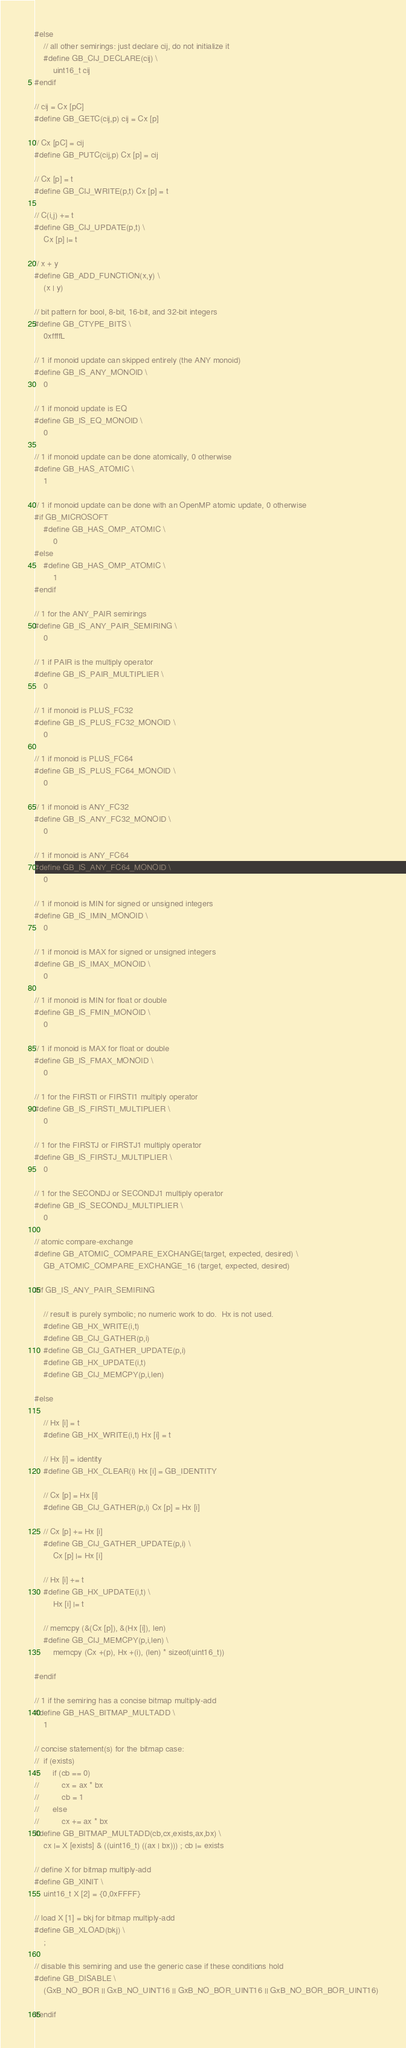Convert code to text. <code><loc_0><loc_0><loc_500><loc_500><_C_>#else
    // all other semirings: just declare cij, do not initialize it
    #define GB_CIJ_DECLARE(cij) \
        uint16_t cij
#endif

// cij = Cx [pC]
#define GB_GETC(cij,p) cij = Cx [p]

// Cx [pC] = cij
#define GB_PUTC(cij,p) Cx [p] = cij

// Cx [p] = t
#define GB_CIJ_WRITE(p,t) Cx [p] = t

// C(i,j) += t
#define GB_CIJ_UPDATE(p,t) \
    Cx [p] |= t

// x + y
#define GB_ADD_FUNCTION(x,y) \
    (x | y)

// bit pattern for bool, 8-bit, 16-bit, and 32-bit integers
#define GB_CTYPE_BITS \
    0xffffL

// 1 if monoid update can skipped entirely (the ANY monoid)
#define GB_IS_ANY_MONOID \
    0

// 1 if monoid update is EQ
#define GB_IS_EQ_MONOID \
    0

// 1 if monoid update can be done atomically, 0 otherwise
#define GB_HAS_ATOMIC \
    1

// 1 if monoid update can be done with an OpenMP atomic update, 0 otherwise
#if GB_MICROSOFT
    #define GB_HAS_OMP_ATOMIC \
        0
#else
    #define GB_HAS_OMP_ATOMIC \
        1
#endif

// 1 for the ANY_PAIR semirings
#define GB_IS_ANY_PAIR_SEMIRING \
    0

// 1 if PAIR is the multiply operator 
#define GB_IS_PAIR_MULTIPLIER \
    0

// 1 if monoid is PLUS_FC32
#define GB_IS_PLUS_FC32_MONOID \
    0

// 1 if monoid is PLUS_FC64
#define GB_IS_PLUS_FC64_MONOID \
    0

// 1 if monoid is ANY_FC32
#define GB_IS_ANY_FC32_MONOID \
    0

// 1 if monoid is ANY_FC64
#define GB_IS_ANY_FC64_MONOID \
    0

// 1 if monoid is MIN for signed or unsigned integers
#define GB_IS_IMIN_MONOID \
    0

// 1 if monoid is MAX for signed or unsigned integers
#define GB_IS_IMAX_MONOID \
    0

// 1 if monoid is MIN for float or double
#define GB_IS_FMIN_MONOID \
    0

// 1 if monoid is MAX for float or double
#define GB_IS_FMAX_MONOID \
    0

// 1 for the FIRSTI or FIRSTI1 multiply operator
#define GB_IS_FIRSTI_MULTIPLIER \
    0

// 1 for the FIRSTJ or FIRSTJ1 multiply operator
#define GB_IS_FIRSTJ_MULTIPLIER \
    0

// 1 for the SECONDJ or SECONDJ1 multiply operator
#define GB_IS_SECONDJ_MULTIPLIER \
    0

// atomic compare-exchange
#define GB_ATOMIC_COMPARE_EXCHANGE(target, expected, desired) \
    GB_ATOMIC_COMPARE_EXCHANGE_16 (target, expected, desired)

#if GB_IS_ANY_PAIR_SEMIRING

    // result is purely symbolic; no numeric work to do.  Hx is not used.
    #define GB_HX_WRITE(i,t)
    #define GB_CIJ_GATHER(p,i)
    #define GB_CIJ_GATHER_UPDATE(p,i)
    #define GB_HX_UPDATE(i,t)
    #define GB_CIJ_MEMCPY(p,i,len)

#else

    // Hx [i] = t
    #define GB_HX_WRITE(i,t) Hx [i] = t

    // Hx [i] = identity
    #define GB_HX_CLEAR(i) Hx [i] = GB_IDENTITY

    // Cx [p] = Hx [i]
    #define GB_CIJ_GATHER(p,i) Cx [p] = Hx [i]

    // Cx [p] += Hx [i]
    #define GB_CIJ_GATHER_UPDATE(p,i) \
        Cx [p] |= Hx [i]

    // Hx [i] += t
    #define GB_HX_UPDATE(i,t) \
        Hx [i] |= t

    // memcpy (&(Cx [p]), &(Hx [i]), len)
    #define GB_CIJ_MEMCPY(p,i,len) \
        memcpy (Cx +(p), Hx +(i), (len) * sizeof(uint16_t))

#endif

// 1 if the semiring has a concise bitmap multiply-add
#define GB_HAS_BITMAP_MULTADD \
    1

// concise statement(s) for the bitmap case:
//  if (exists)
//      if (cb == 0)
//          cx = ax * bx
//          cb = 1
//      else
//          cx += ax * bx
#define GB_BITMAP_MULTADD(cb,cx,exists,ax,bx) \
    cx |= X [exists] & ((uint16_t) ((ax | bx))) ; cb |= exists

// define X for bitmap multiply-add
#define GB_XINIT \
    uint16_t X [2] = {0,0xFFFF}

// load X [1] = bkj for bitmap multiply-add
#define GB_XLOAD(bkj) \
    ;

// disable this semiring and use the generic case if these conditions hold
#define GB_DISABLE \
    (GxB_NO_BOR || GxB_NO_UINT16 || GxB_NO_BOR_UINT16 || GxB_NO_BOR_BOR_UINT16)

#endif

</code> 